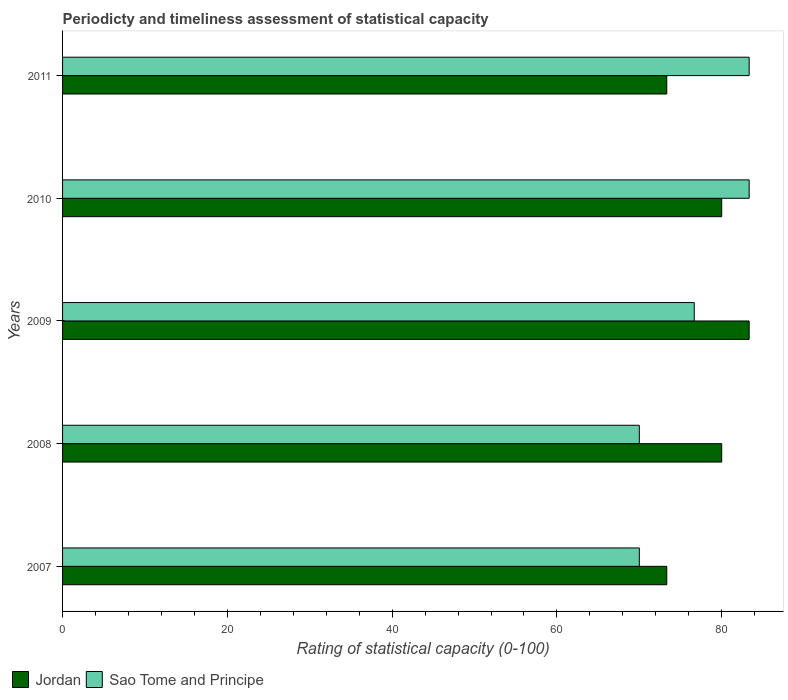How many different coloured bars are there?
Your answer should be very brief. 2. Are the number of bars per tick equal to the number of legend labels?
Give a very brief answer. Yes. How many bars are there on the 1st tick from the bottom?
Give a very brief answer. 2. What is the label of the 5th group of bars from the top?
Your answer should be compact. 2007. In how many cases, is the number of bars for a given year not equal to the number of legend labels?
Ensure brevity in your answer.  0. What is the rating of statistical capacity in Jordan in 2011?
Provide a succinct answer. 73.33. Across all years, what is the maximum rating of statistical capacity in Jordan?
Offer a terse response. 83.33. In which year was the rating of statistical capacity in Sao Tome and Principe maximum?
Make the answer very short. 2010. What is the total rating of statistical capacity in Sao Tome and Principe in the graph?
Make the answer very short. 383.33. What is the difference between the rating of statistical capacity in Sao Tome and Principe in 2009 and the rating of statistical capacity in Jordan in 2007?
Your answer should be compact. 3.33. What is the average rating of statistical capacity in Jordan per year?
Give a very brief answer. 78. In how many years, is the rating of statistical capacity in Jordan greater than 48 ?
Your answer should be very brief. 5. What is the ratio of the rating of statistical capacity in Jordan in 2008 to that in 2010?
Ensure brevity in your answer.  1. Is the rating of statistical capacity in Jordan in 2007 less than that in 2011?
Ensure brevity in your answer.  No. Is the difference between the rating of statistical capacity in Jordan in 2007 and 2010 greater than the difference between the rating of statistical capacity in Sao Tome and Principe in 2007 and 2010?
Your answer should be very brief. Yes. What is the difference between the highest and the second highest rating of statistical capacity in Sao Tome and Principe?
Ensure brevity in your answer.  0. What is the difference between the highest and the lowest rating of statistical capacity in Sao Tome and Principe?
Your response must be concise. 13.33. Is the sum of the rating of statistical capacity in Sao Tome and Principe in 2007 and 2011 greater than the maximum rating of statistical capacity in Jordan across all years?
Keep it short and to the point. Yes. What does the 1st bar from the top in 2009 represents?
Offer a very short reply. Sao Tome and Principe. What does the 1st bar from the bottom in 2010 represents?
Ensure brevity in your answer.  Jordan. How many bars are there?
Give a very brief answer. 10. Does the graph contain any zero values?
Your response must be concise. No. Does the graph contain grids?
Your answer should be compact. No. Where does the legend appear in the graph?
Offer a terse response. Bottom left. How are the legend labels stacked?
Provide a short and direct response. Horizontal. What is the title of the graph?
Make the answer very short. Periodicty and timeliness assessment of statistical capacity. What is the label or title of the X-axis?
Provide a short and direct response. Rating of statistical capacity (0-100). What is the label or title of the Y-axis?
Ensure brevity in your answer.  Years. What is the Rating of statistical capacity (0-100) in Jordan in 2007?
Provide a succinct answer. 73.33. What is the Rating of statistical capacity (0-100) of Sao Tome and Principe in 2007?
Offer a very short reply. 70. What is the Rating of statistical capacity (0-100) of Jordan in 2009?
Ensure brevity in your answer.  83.33. What is the Rating of statistical capacity (0-100) in Sao Tome and Principe in 2009?
Offer a very short reply. 76.67. What is the Rating of statistical capacity (0-100) of Sao Tome and Principe in 2010?
Give a very brief answer. 83.33. What is the Rating of statistical capacity (0-100) in Jordan in 2011?
Offer a terse response. 73.33. What is the Rating of statistical capacity (0-100) in Sao Tome and Principe in 2011?
Give a very brief answer. 83.33. Across all years, what is the maximum Rating of statistical capacity (0-100) in Jordan?
Your answer should be very brief. 83.33. Across all years, what is the maximum Rating of statistical capacity (0-100) of Sao Tome and Principe?
Offer a terse response. 83.33. Across all years, what is the minimum Rating of statistical capacity (0-100) of Jordan?
Provide a succinct answer. 73.33. What is the total Rating of statistical capacity (0-100) in Jordan in the graph?
Give a very brief answer. 390. What is the total Rating of statistical capacity (0-100) in Sao Tome and Principe in the graph?
Give a very brief answer. 383.33. What is the difference between the Rating of statistical capacity (0-100) in Jordan in 2007 and that in 2008?
Your response must be concise. -6.67. What is the difference between the Rating of statistical capacity (0-100) of Sao Tome and Principe in 2007 and that in 2008?
Provide a succinct answer. 0. What is the difference between the Rating of statistical capacity (0-100) in Jordan in 2007 and that in 2009?
Keep it short and to the point. -10. What is the difference between the Rating of statistical capacity (0-100) of Sao Tome and Principe in 2007 and that in 2009?
Ensure brevity in your answer.  -6.67. What is the difference between the Rating of statistical capacity (0-100) in Jordan in 2007 and that in 2010?
Provide a short and direct response. -6.67. What is the difference between the Rating of statistical capacity (0-100) in Sao Tome and Principe in 2007 and that in 2010?
Make the answer very short. -13.33. What is the difference between the Rating of statistical capacity (0-100) in Sao Tome and Principe in 2007 and that in 2011?
Make the answer very short. -13.33. What is the difference between the Rating of statistical capacity (0-100) of Jordan in 2008 and that in 2009?
Your answer should be compact. -3.33. What is the difference between the Rating of statistical capacity (0-100) of Sao Tome and Principe in 2008 and that in 2009?
Make the answer very short. -6.67. What is the difference between the Rating of statistical capacity (0-100) of Sao Tome and Principe in 2008 and that in 2010?
Make the answer very short. -13.33. What is the difference between the Rating of statistical capacity (0-100) in Sao Tome and Principe in 2008 and that in 2011?
Offer a terse response. -13.33. What is the difference between the Rating of statistical capacity (0-100) in Sao Tome and Principe in 2009 and that in 2010?
Keep it short and to the point. -6.67. What is the difference between the Rating of statistical capacity (0-100) of Sao Tome and Principe in 2009 and that in 2011?
Your answer should be compact. -6.67. What is the difference between the Rating of statistical capacity (0-100) in Jordan in 2010 and that in 2011?
Make the answer very short. 6.67. What is the difference between the Rating of statistical capacity (0-100) of Jordan in 2007 and the Rating of statistical capacity (0-100) of Sao Tome and Principe in 2011?
Make the answer very short. -10. What is the difference between the Rating of statistical capacity (0-100) of Jordan in 2008 and the Rating of statistical capacity (0-100) of Sao Tome and Principe in 2009?
Make the answer very short. 3.33. What is the difference between the Rating of statistical capacity (0-100) in Jordan in 2008 and the Rating of statistical capacity (0-100) in Sao Tome and Principe in 2010?
Your answer should be very brief. -3.33. What is the difference between the Rating of statistical capacity (0-100) of Jordan in 2009 and the Rating of statistical capacity (0-100) of Sao Tome and Principe in 2010?
Your response must be concise. 0. What is the difference between the Rating of statistical capacity (0-100) in Jordan in 2009 and the Rating of statistical capacity (0-100) in Sao Tome and Principe in 2011?
Offer a terse response. 0. What is the average Rating of statistical capacity (0-100) in Jordan per year?
Offer a terse response. 78. What is the average Rating of statistical capacity (0-100) in Sao Tome and Principe per year?
Give a very brief answer. 76.67. In the year 2009, what is the difference between the Rating of statistical capacity (0-100) of Jordan and Rating of statistical capacity (0-100) of Sao Tome and Principe?
Give a very brief answer. 6.67. In the year 2011, what is the difference between the Rating of statistical capacity (0-100) of Jordan and Rating of statistical capacity (0-100) of Sao Tome and Principe?
Your answer should be very brief. -10. What is the ratio of the Rating of statistical capacity (0-100) in Jordan in 2007 to that in 2009?
Your response must be concise. 0.88. What is the ratio of the Rating of statistical capacity (0-100) in Sao Tome and Principe in 2007 to that in 2010?
Make the answer very short. 0.84. What is the ratio of the Rating of statistical capacity (0-100) in Jordan in 2007 to that in 2011?
Give a very brief answer. 1. What is the ratio of the Rating of statistical capacity (0-100) in Sao Tome and Principe in 2007 to that in 2011?
Ensure brevity in your answer.  0.84. What is the ratio of the Rating of statistical capacity (0-100) in Jordan in 2008 to that in 2010?
Offer a very short reply. 1. What is the ratio of the Rating of statistical capacity (0-100) of Sao Tome and Principe in 2008 to that in 2010?
Provide a short and direct response. 0.84. What is the ratio of the Rating of statistical capacity (0-100) of Sao Tome and Principe in 2008 to that in 2011?
Provide a succinct answer. 0.84. What is the ratio of the Rating of statistical capacity (0-100) in Jordan in 2009 to that in 2010?
Your response must be concise. 1.04. What is the ratio of the Rating of statistical capacity (0-100) in Jordan in 2009 to that in 2011?
Make the answer very short. 1.14. What is the ratio of the Rating of statistical capacity (0-100) in Sao Tome and Principe in 2010 to that in 2011?
Give a very brief answer. 1. What is the difference between the highest and the second highest Rating of statistical capacity (0-100) in Sao Tome and Principe?
Make the answer very short. 0. What is the difference between the highest and the lowest Rating of statistical capacity (0-100) of Sao Tome and Principe?
Your response must be concise. 13.33. 